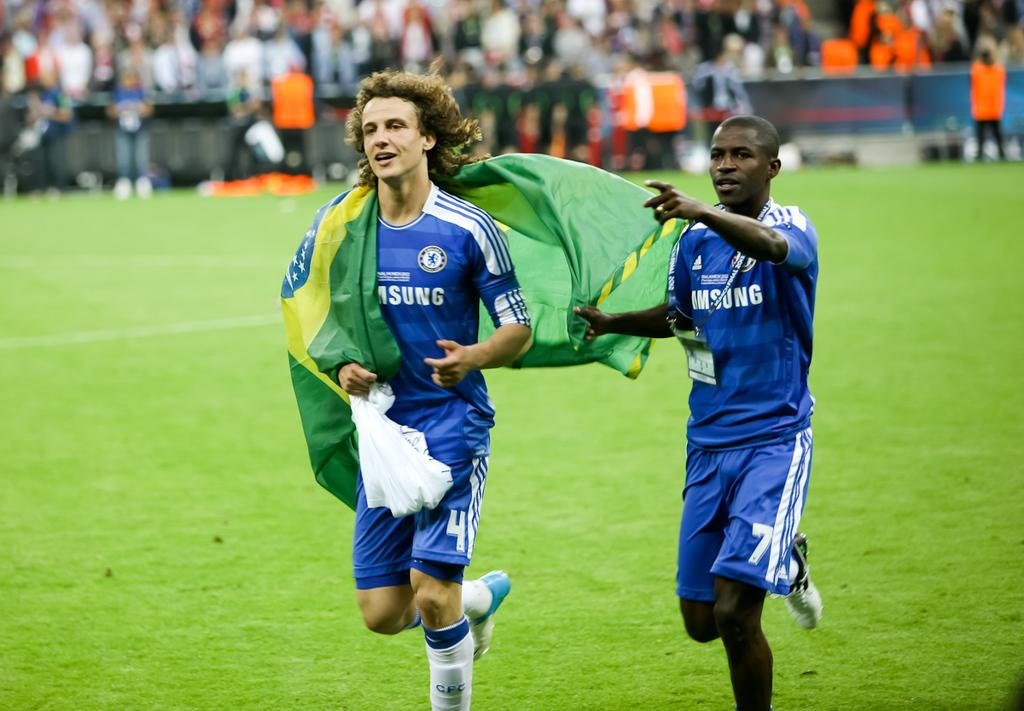<image>
Offer a succinct explanation of the picture presented. Two soccer players wearing blue jerseys only half the word is showing saying sung 